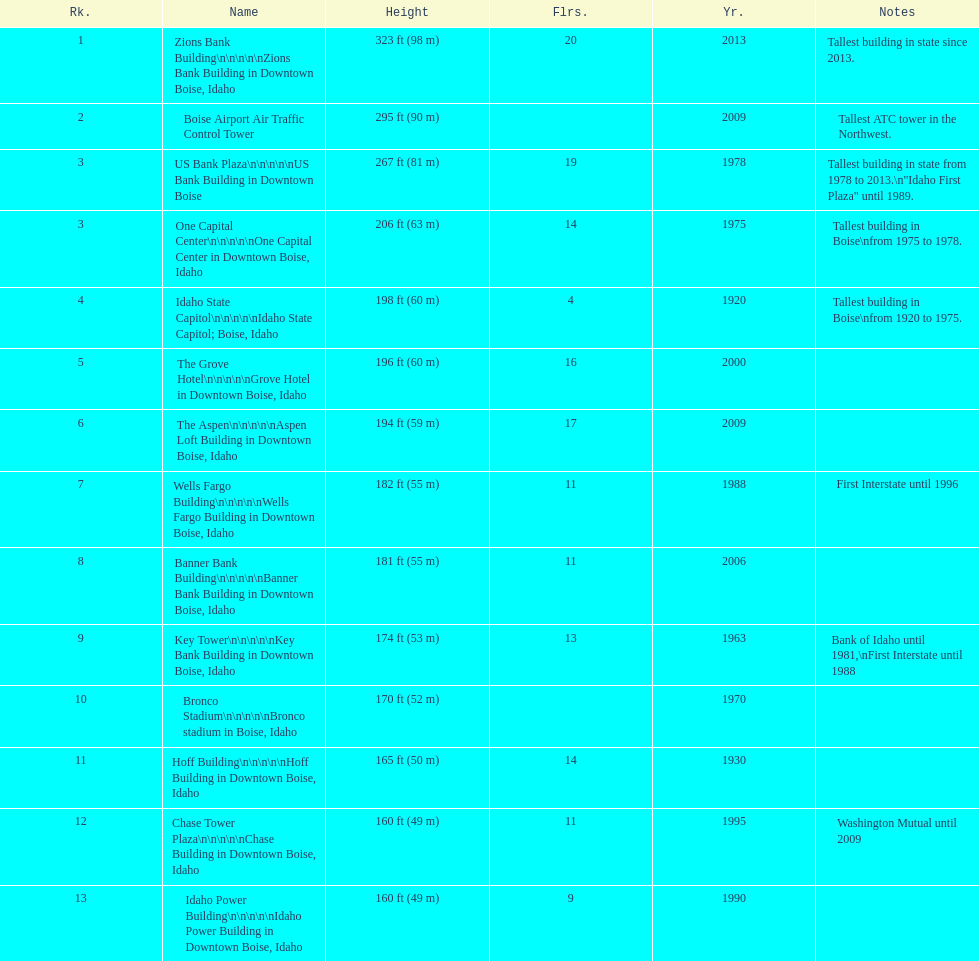Could you parse the entire table? {'header': ['Rk.', 'Name', 'Height', 'Flrs.', 'Yr.', 'Notes'], 'rows': [['1', 'Zions Bank Building\\n\\n\\n\\n\\nZions Bank Building in Downtown Boise, Idaho', '323\xa0ft (98\xa0m)', '20', '2013', 'Tallest building in state since 2013.'], ['2', 'Boise Airport Air Traffic Control Tower', '295\xa0ft (90\xa0m)', '', '2009', 'Tallest ATC tower in the Northwest.'], ['3', 'US Bank Plaza\\n\\n\\n\\n\\nUS Bank Building in Downtown Boise', '267\xa0ft (81\xa0m)', '19', '1978', 'Tallest building in state from 1978 to 2013.\\n"Idaho First Plaza" until 1989.'], ['3', 'One Capital Center\\n\\n\\n\\n\\nOne Capital Center in Downtown Boise, Idaho', '206\xa0ft (63\xa0m)', '14', '1975', 'Tallest building in Boise\\nfrom 1975 to 1978.'], ['4', 'Idaho State Capitol\\n\\n\\n\\n\\nIdaho State Capitol; Boise, Idaho', '198\xa0ft (60\xa0m)', '4', '1920', 'Tallest building in Boise\\nfrom 1920 to 1975.'], ['5', 'The Grove Hotel\\n\\n\\n\\n\\nGrove Hotel in Downtown Boise, Idaho', '196\xa0ft (60\xa0m)', '16', '2000', ''], ['6', 'The Aspen\\n\\n\\n\\n\\nAspen Loft Building in Downtown Boise, Idaho', '194\xa0ft (59\xa0m)', '17', '2009', ''], ['7', 'Wells Fargo Building\\n\\n\\n\\n\\nWells Fargo Building in Downtown Boise, Idaho', '182\xa0ft (55\xa0m)', '11', '1988', 'First Interstate until 1996'], ['8', 'Banner Bank Building\\n\\n\\n\\n\\nBanner Bank Building in Downtown Boise, Idaho', '181\xa0ft (55\xa0m)', '11', '2006', ''], ['9', 'Key Tower\\n\\n\\n\\n\\nKey Bank Building in Downtown Boise, Idaho', '174\xa0ft (53\xa0m)', '13', '1963', 'Bank of Idaho until 1981,\\nFirst Interstate until 1988'], ['10', 'Bronco Stadium\\n\\n\\n\\n\\nBronco stadium in Boise, Idaho', '170\xa0ft (52\xa0m)', '', '1970', ''], ['11', 'Hoff Building\\n\\n\\n\\n\\nHoff Building in Downtown Boise, Idaho', '165\xa0ft (50\xa0m)', '14', '1930', ''], ['12', 'Chase Tower Plaza\\n\\n\\n\\n\\nChase Building in Downtown Boise, Idaho', '160\xa0ft (49\xa0m)', '11', '1995', 'Washington Mutual until 2009'], ['13', 'Idaho Power Building\\n\\n\\n\\n\\nIdaho Power Building in Downtown Boise, Idaho', '160\xa0ft (49\xa0m)', '9', '1990', '']]} How many of these buildings were built after 1975 8. 